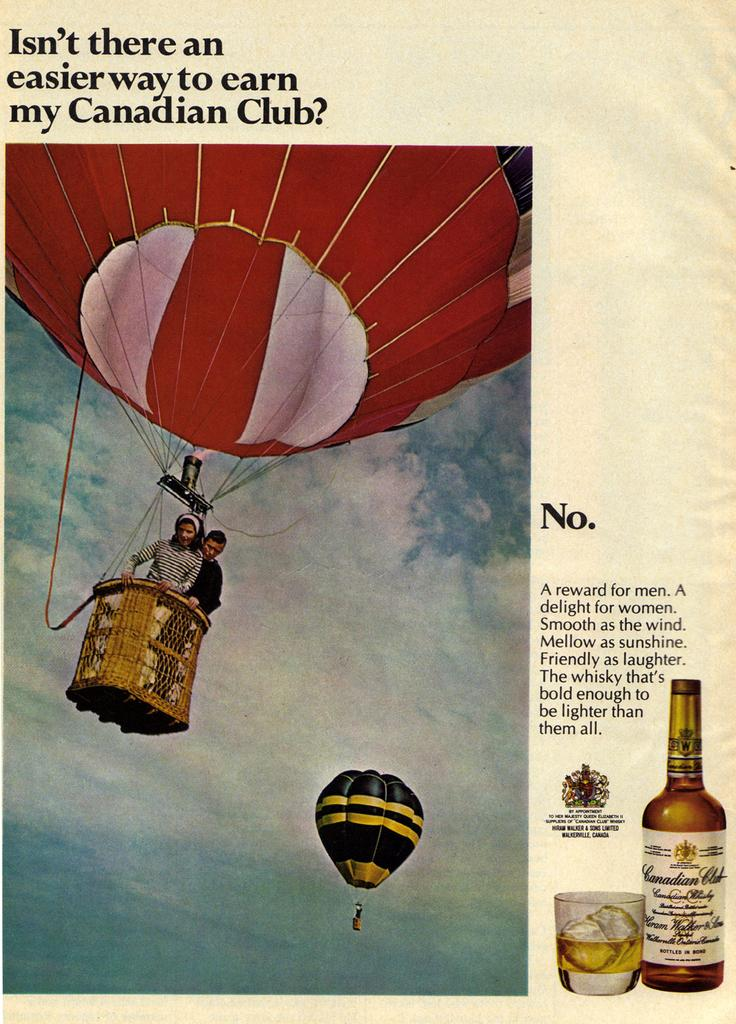Provide a one-sentence caption for the provided image. a sheet of paper about earning in a Canadian club. 